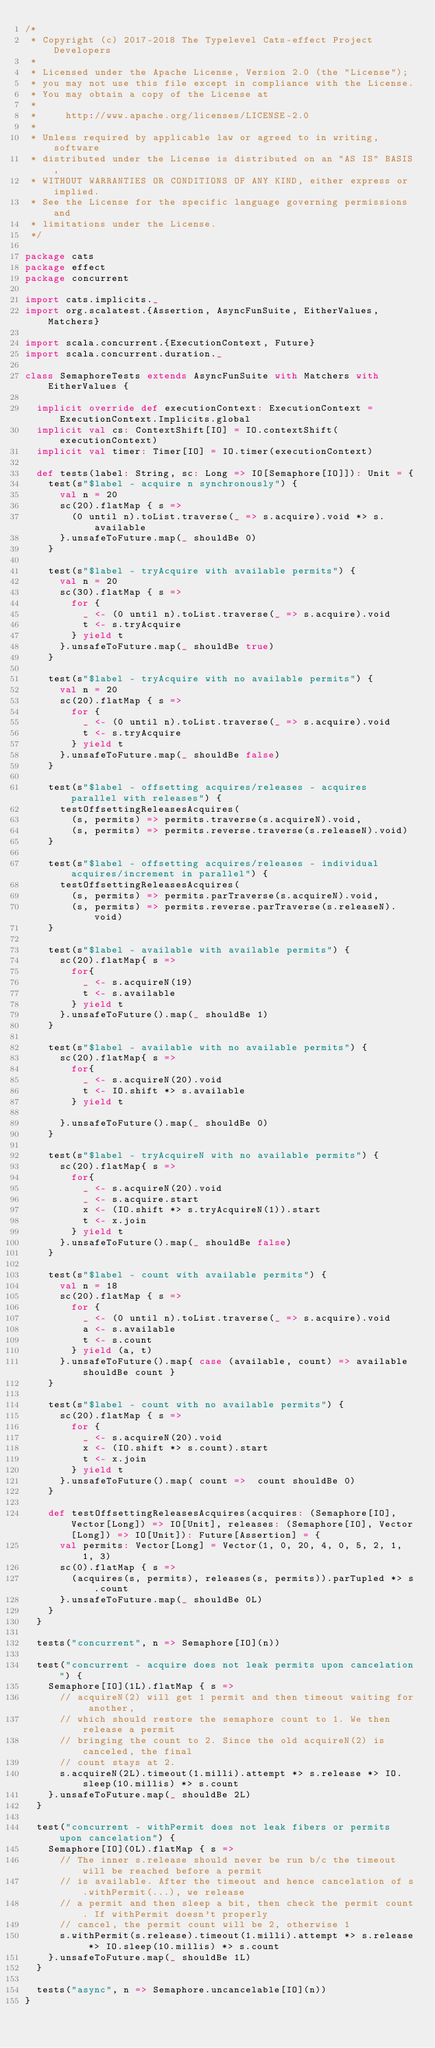<code> <loc_0><loc_0><loc_500><loc_500><_Scala_>/*
 * Copyright (c) 2017-2018 The Typelevel Cats-effect Project Developers
 *
 * Licensed under the Apache License, Version 2.0 (the "License");
 * you may not use this file except in compliance with the License.
 * You may obtain a copy of the License at
 *
 *     http://www.apache.org/licenses/LICENSE-2.0
 *
 * Unless required by applicable law or agreed to in writing, software
 * distributed under the License is distributed on an "AS IS" BASIS,
 * WITHOUT WARRANTIES OR CONDITIONS OF ANY KIND, either express or implied.
 * See the License for the specific language governing permissions and
 * limitations under the License.
 */

package cats
package effect
package concurrent

import cats.implicits._
import org.scalatest.{Assertion, AsyncFunSuite, EitherValues, Matchers}

import scala.concurrent.{ExecutionContext, Future}
import scala.concurrent.duration._

class SemaphoreTests extends AsyncFunSuite with Matchers with EitherValues {

  implicit override def executionContext: ExecutionContext = ExecutionContext.Implicits.global
  implicit val cs: ContextShift[IO] = IO.contextShift(executionContext)
  implicit val timer: Timer[IO] = IO.timer(executionContext)

  def tests(label: String, sc: Long => IO[Semaphore[IO]]): Unit = {
    test(s"$label - acquire n synchronously") {
      val n = 20
      sc(20).flatMap { s =>
        (0 until n).toList.traverse(_ => s.acquire).void *> s.available
      }.unsafeToFuture.map(_ shouldBe 0)
    }

    test(s"$label - tryAcquire with available permits") {
      val n = 20
      sc(30).flatMap { s =>
        for {
          _ <- (0 until n).toList.traverse(_ => s.acquire).void
          t <- s.tryAcquire
        } yield t
      }.unsafeToFuture.map(_ shouldBe true)
    }

    test(s"$label - tryAcquire with no available permits") {
      val n = 20
      sc(20).flatMap { s =>
        for {
          _ <- (0 until n).toList.traverse(_ => s.acquire).void
          t <- s.tryAcquire
        } yield t
      }.unsafeToFuture.map(_ shouldBe false)
    }

    test(s"$label - offsetting acquires/releases - acquires parallel with releases") {
      testOffsettingReleasesAcquires(
        (s, permits) => permits.traverse(s.acquireN).void,
        (s, permits) => permits.reverse.traverse(s.releaseN).void)
    }

    test(s"$label - offsetting acquires/releases - individual acquires/increment in parallel") {
      testOffsettingReleasesAcquires(
        (s, permits) => permits.parTraverse(s.acquireN).void,
        (s, permits) => permits.reverse.parTraverse(s.releaseN).void)
    }

    test(s"$label - available with available permits") {
      sc(20).flatMap{ s =>
        for{
          _ <- s.acquireN(19)
          t <- s.available
        } yield t
      }.unsafeToFuture().map(_ shouldBe 1)
    }

    test(s"$label - available with no available permits") {
      sc(20).flatMap{ s =>
        for{
          _ <- s.acquireN(20).void
          t <- IO.shift *> s.available
        } yield t

      }.unsafeToFuture().map(_ shouldBe 0)
    }

    test(s"$label - tryAcquireN with no available permits") {
      sc(20).flatMap{ s =>
        for{
          _ <- s.acquireN(20).void
          _ <- s.acquire.start
          x <- (IO.shift *> s.tryAcquireN(1)).start
          t <- x.join
        } yield t
      }.unsafeToFuture().map(_ shouldBe false)
    }

    test(s"$label - count with available permits") {
      val n = 18
      sc(20).flatMap { s =>
        for {
          _ <- (0 until n).toList.traverse(_ => s.acquire).void
          a <- s.available
          t <- s.count
        } yield (a, t)
      }.unsafeToFuture().map{ case (available, count) => available shouldBe count }
    }

    test(s"$label - count with no available permits") {
      sc(20).flatMap { s =>
        for {
          _ <- s.acquireN(20).void
          x <- (IO.shift *> s.count).start
          t <- x.join
        } yield t
      }.unsafeToFuture().map( count =>  count shouldBe 0)
    }

    def testOffsettingReleasesAcquires(acquires: (Semaphore[IO], Vector[Long]) => IO[Unit], releases: (Semaphore[IO], Vector[Long]) => IO[Unit]): Future[Assertion] = {
      val permits: Vector[Long] = Vector(1, 0, 20, 4, 0, 5, 2, 1, 1, 3)
      sc(0).flatMap { s =>
        (acquires(s, permits), releases(s, permits)).parTupled *> s.count
      }.unsafeToFuture.map(_ shouldBe 0L)
    }
  }

  tests("concurrent", n => Semaphore[IO](n))

  test("concurrent - acquire does not leak permits upon cancelation") {
    Semaphore[IO](1L).flatMap { s =>
      // acquireN(2) will get 1 permit and then timeout waiting for another,
      // which should restore the semaphore count to 1. We then release a permit
      // bringing the count to 2. Since the old acquireN(2) is canceled, the final
      // count stays at 2.
      s.acquireN(2L).timeout(1.milli).attempt *> s.release *> IO.sleep(10.millis) *> s.count
    }.unsafeToFuture.map(_ shouldBe 2L)
  }

  test("concurrent - withPermit does not leak fibers or permits upon cancelation") {
    Semaphore[IO](0L).flatMap { s =>
      // The inner s.release should never be run b/c the timeout will be reached before a permit
      // is available. After the timeout and hence cancelation of s.withPermit(...), we release
      // a permit and then sleep a bit, then check the permit count. If withPermit doesn't properly
      // cancel, the permit count will be 2, otherwise 1
      s.withPermit(s.release).timeout(1.milli).attempt *> s.release *> IO.sleep(10.millis) *> s.count
    }.unsafeToFuture.map(_ shouldBe 1L)
  }

  tests("async", n => Semaphore.uncancelable[IO](n))
}
</code> 